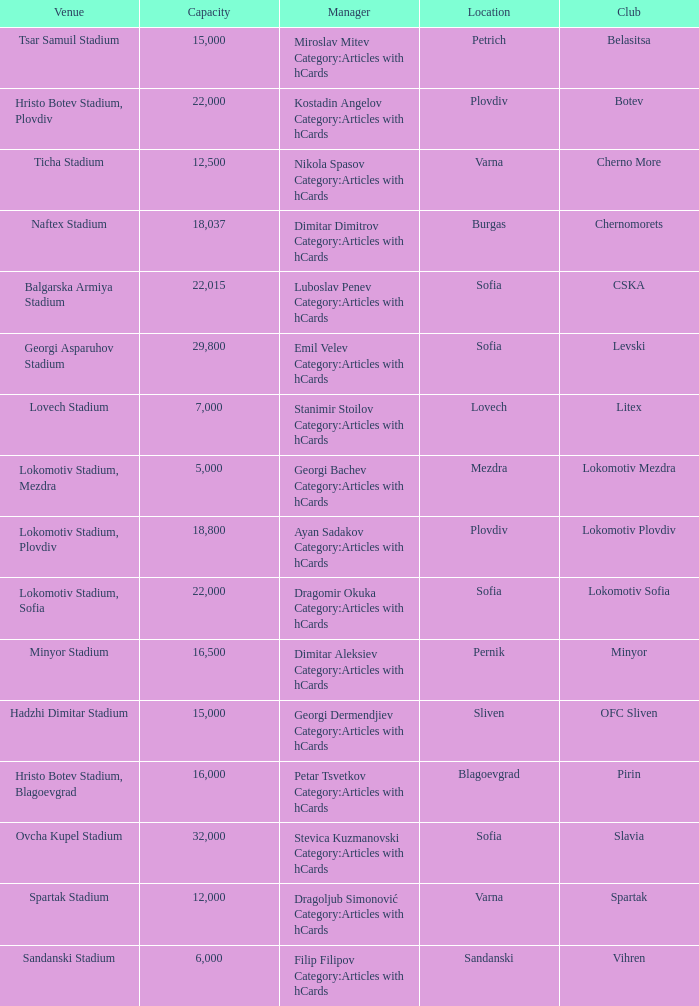What is the total number of capacity for the venue of the club, pirin? 1.0. 